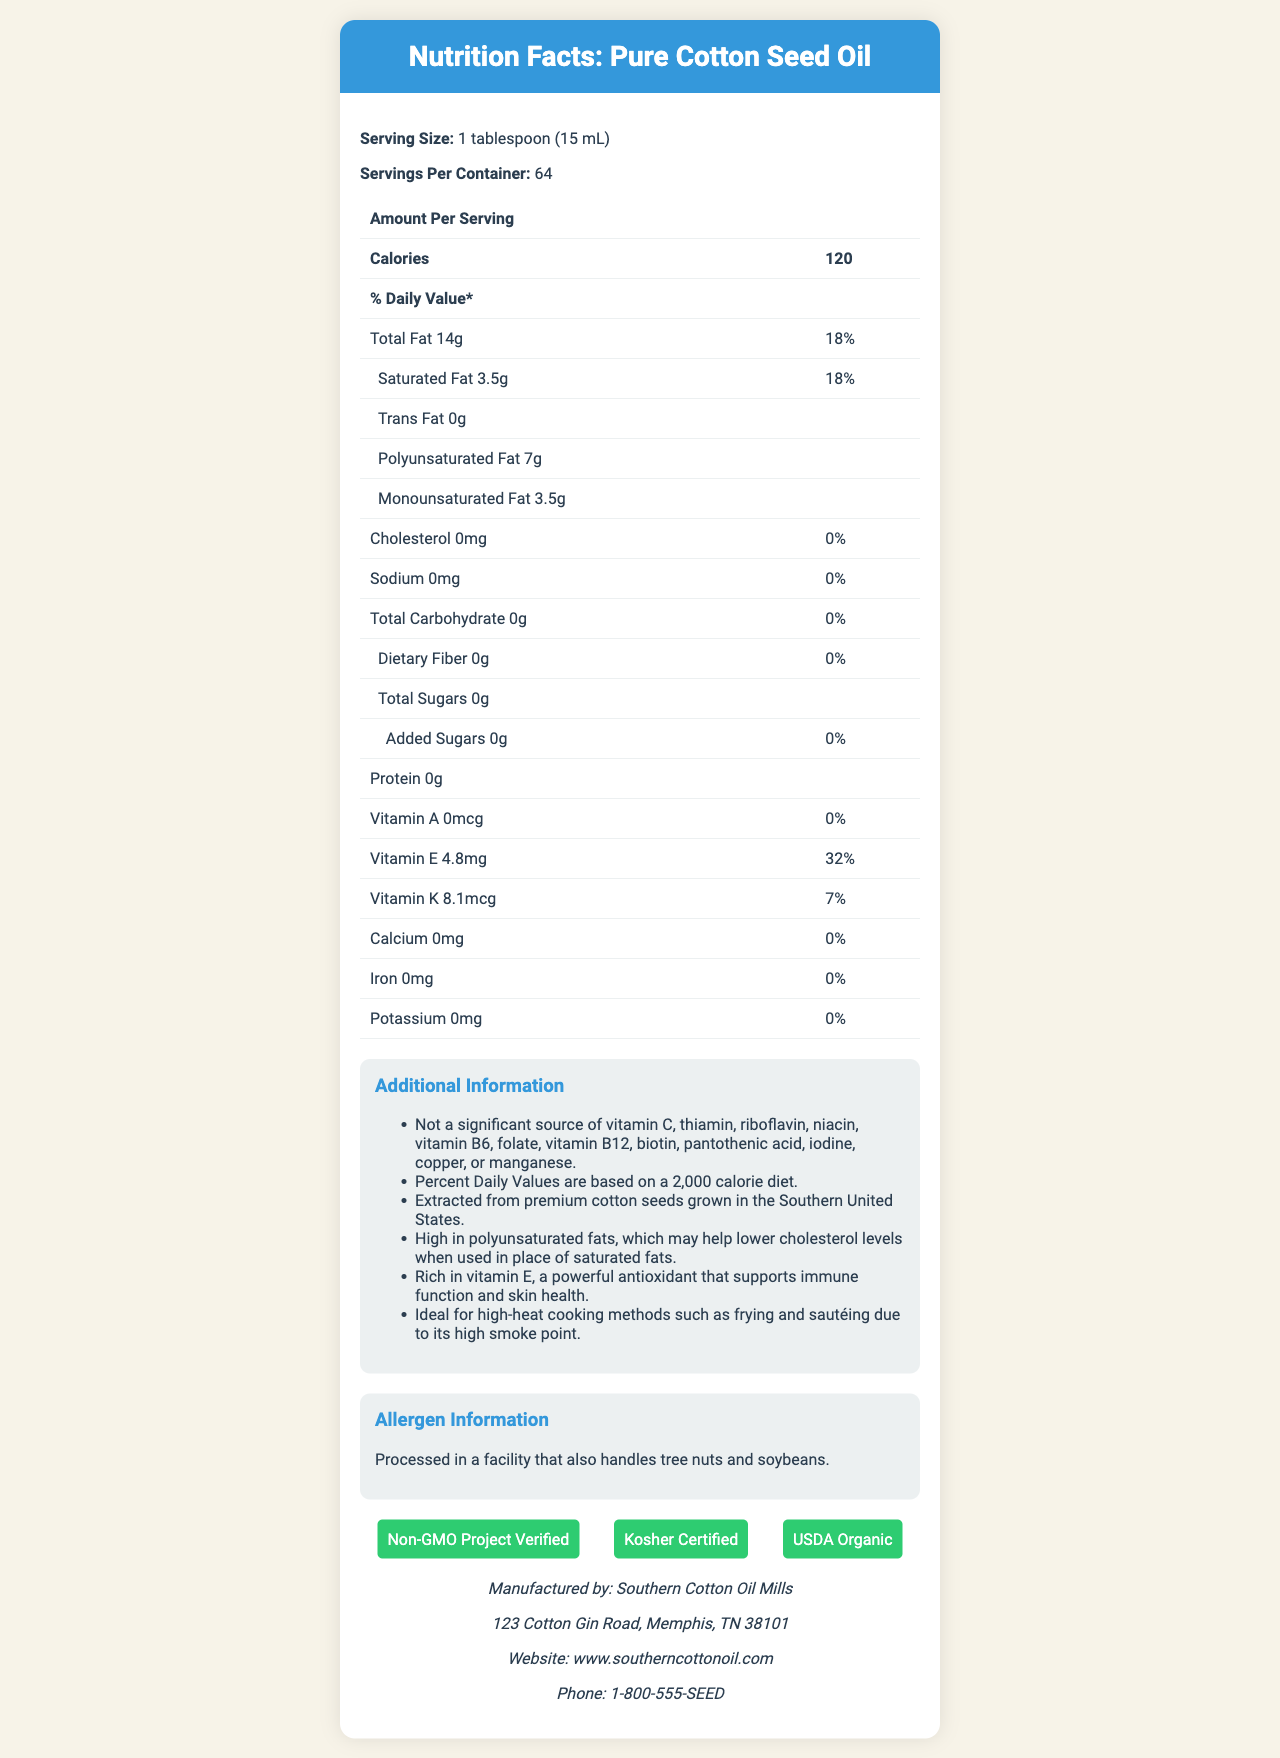What is the serving size for Pure Cotton Seed Oil? The serving size is clearly stated at the beginning of the document as "1 tablespoon (15 mL)."
Answer: 1 tablespoon (15 mL) How many calories are there in one serving of Pure Cotton Seed Oil? The document states that there are 120 calories per serving.
Answer: 120 What percentage of the daily value of vitamin E is provided in one serving? The document lists vitamin E content as 4.8mg and its daily value as 32%.
Answer: 32% How much polyunsaturated fat is there per serving? The document specifies that each serving contains 7 grams of polyunsaturated fat.
Answer: 7g Which vitamins and minerals are mentioned as not being significant sources in the additional info section? According to the additional information, Pure Cotton Seed Oil is not a significant source of these vitamins and minerals.
Answer: Vitamin C, thiamin, riboflavin, niacin, vitamin B6, folate, vitamin B12, biotin, pantothenic acid, iodine, copper, manganese How many certifications does Pure Cotton Seed Oil have? A. 1 B. 3 C. 4 D. 2 The document lists three certifications: Non-GMO Project Verified, Kosher Certified, and USDA Organic.
Answer: B. 3 What is the manufacturer's phone number? A. 1-800-555-SEED B. 1-800-555-OIL C. 1-800-123-SEED D. 1-800-555-COTN The manufacturer's phone number is listed as 1-800-555-SEED in the manufacturer's info section.
Answer: A. 1-800-555-SEED Does Pure Cotton Seed Oil contain any cholesterol? The document states that the cholesterol amount per serving is 0mg and the daily value is 0%.
Answer: No Summarize the main nutritional highlights and certifications found in the document. The document highlights the nutritional content, mainly fats and vitamins E and K, and certifications including Non-GMO Project Verified, Kosher Certified, and USDA Organic. It also provides additional health claims and allergen information.
Answer: Pure Cotton Seed Oil is high in calories and fats with 14g total fat and 120 calories per serving. It contains vitamin E (4.8mg, 32% daily value) and vitamin K (8.1mcg, 7% daily value). The oil is non-GMO, kosher certified, and USDA Organic. It’s noted for being high in polyunsaturated fats, ideal for high-heat cooking, and processed in a facility that handles nuts and soybeans. What is the sodium content per serving? The document specifies that the sodium content per serving is 0mg.
Answer: 0mg Is the product high in dietary fiber? The dietary fiber content is 0g and the daily value is 0%, indicating it is not high in dietary fiber.
Answer: No Can this oil be used for high-heat cooking methods? The additional info section states that Pure Cotton Seed Oil is ideal for high-heat cooking methods such as frying and sautéing due to its high smoke point.
Answer: Yes Which vitamins are present in Pure Cotton Seed Oil? The document lists vitamin E (4.8mg, 32% daily value) and vitamin K (8.1mcg, 7% daily value) as present in the oil.
Answer: Vitamin E and Vitamin K Are there any added sugars in the product? Both the total sugars and added sugars amounts are listed as 0g, meaning there are no added sugars.
Answer: No How many grams of monounsaturated fat are in one tablespoon of Pure Cotton Seed Oil? The document states that there are 3.5 grams of monounsaturated fat per serving.
Answer: 3.5g What other products are processed in the same facility as Pure Cotton Seed Oil? The allergen info section states that the oil is processed in a facility that also handles tree nuts and soybeans.
Answer: Tree nuts and soybeans How is the daily value percentage for total fat calculated? The document does not provide the exact method for calculating the daily value percentage for total fat.
Answer: Cannot be determined 